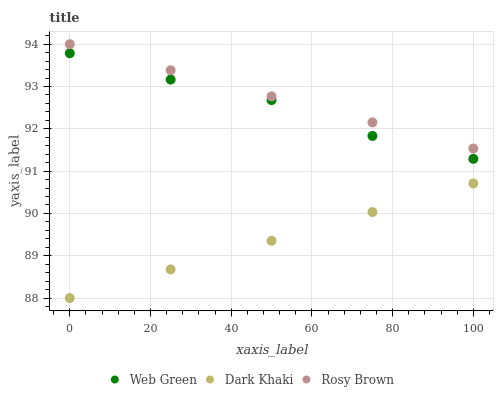Does Dark Khaki have the minimum area under the curve?
Answer yes or no. Yes. Does Rosy Brown have the maximum area under the curve?
Answer yes or no. Yes. Does Web Green have the minimum area under the curve?
Answer yes or no. No. Does Web Green have the maximum area under the curve?
Answer yes or no. No. Is Dark Khaki the smoothest?
Answer yes or no. Yes. Is Web Green the roughest?
Answer yes or no. Yes. Is Web Green the smoothest?
Answer yes or no. No. Is Rosy Brown the roughest?
Answer yes or no. No. Does Dark Khaki have the lowest value?
Answer yes or no. Yes. Does Web Green have the lowest value?
Answer yes or no. No. Does Rosy Brown have the highest value?
Answer yes or no. Yes. Does Web Green have the highest value?
Answer yes or no. No. Is Dark Khaki less than Web Green?
Answer yes or no. Yes. Is Rosy Brown greater than Web Green?
Answer yes or no. Yes. Does Dark Khaki intersect Web Green?
Answer yes or no. No. 